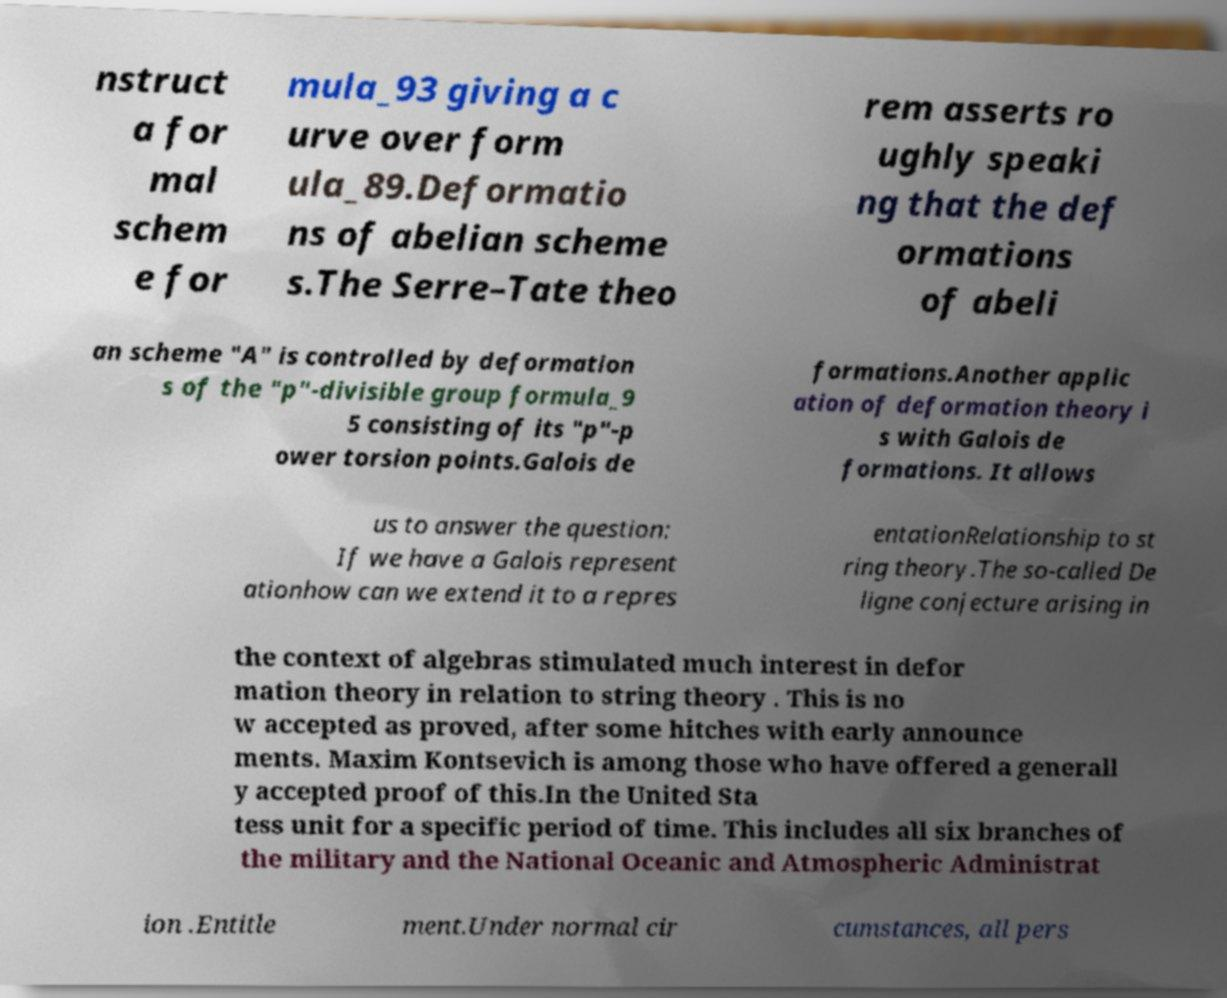Please identify and transcribe the text found in this image. nstruct a for mal schem e for mula_93 giving a c urve over form ula_89.Deformatio ns of abelian scheme s.The Serre–Tate theo rem asserts ro ughly speaki ng that the def ormations of abeli an scheme "A" is controlled by deformation s of the "p"-divisible group formula_9 5 consisting of its "p"-p ower torsion points.Galois de formations.Another applic ation of deformation theory i s with Galois de formations. It allows us to answer the question: If we have a Galois represent ationhow can we extend it to a repres entationRelationship to st ring theory.The so-called De ligne conjecture arising in the context of algebras stimulated much interest in defor mation theory in relation to string theory . This is no w accepted as proved, after some hitches with early announce ments. Maxim Kontsevich is among those who have offered a generall y accepted proof of this.In the United Sta tess unit for a specific period of time. This includes all six branches of the military and the National Oceanic and Atmospheric Administrat ion .Entitle ment.Under normal cir cumstances, all pers 